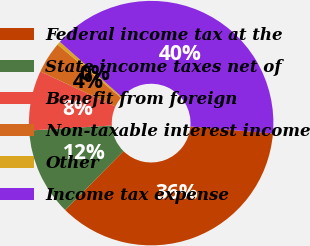Convert chart. <chart><loc_0><loc_0><loc_500><loc_500><pie_chart><fcel>Federal income tax at the<fcel>State income taxes net of<fcel>Benefit from foreign<fcel>Non-taxable interest income<fcel>Other<fcel>Income tax expense<nl><fcel>36.05%<fcel>11.62%<fcel>7.9%<fcel>4.18%<fcel>0.46%<fcel>39.77%<nl></chart> 